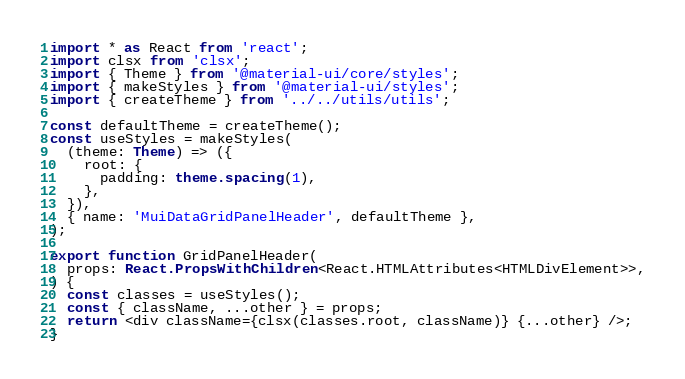Convert code to text. <code><loc_0><loc_0><loc_500><loc_500><_TypeScript_>import * as React from 'react';
import clsx from 'clsx';
import { Theme } from '@material-ui/core/styles';
import { makeStyles } from '@material-ui/styles';
import { createTheme } from '../../utils/utils';

const defaultTheme = createTheme();
const useStyles = makeStyles(
  (theme: Theme) => ({
    root: {
      padding: theme.spacing(1),
    },
  }),
  { name: 'MuiDataGridPanelHeader', defaultTheme },
);

export function GridPanelHeader(
  props: React.PropsWithChildren<React.HTMLAttributes<HTMLDivElement>>,
) {
  const classes = useStyles();
  const { className, ...other } = props;
  return <div className={clsx(classes.root, className)} {...other} />;
}
</code> 